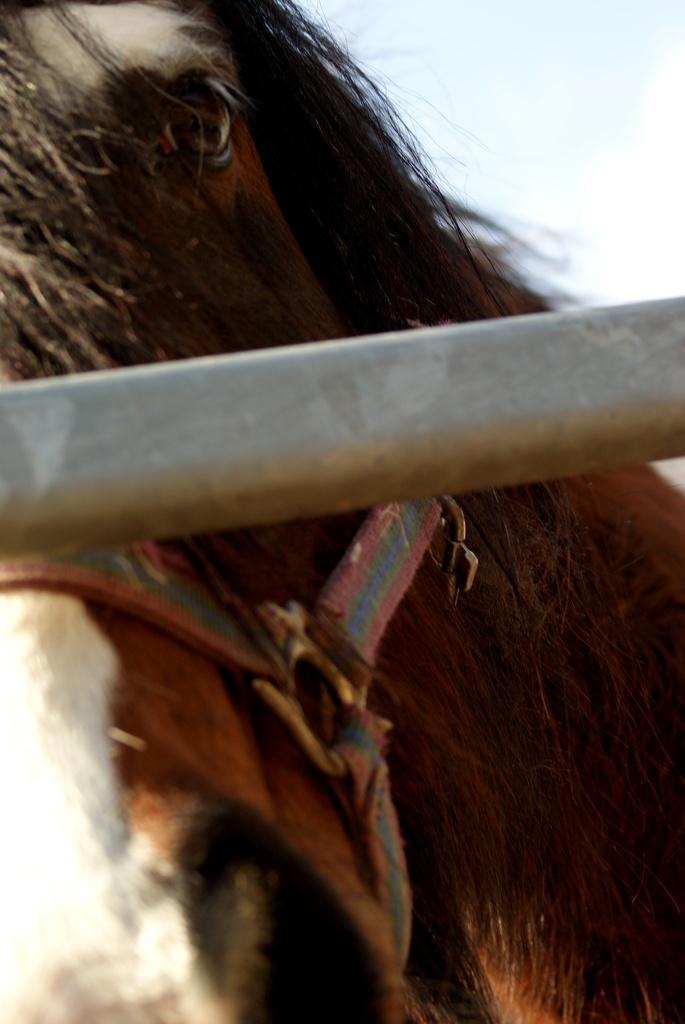How would you summarize this image in a sentence or two? Here we can see a pole and behind it there is a horse with a belt tied to its head. In the background there is a sky. 